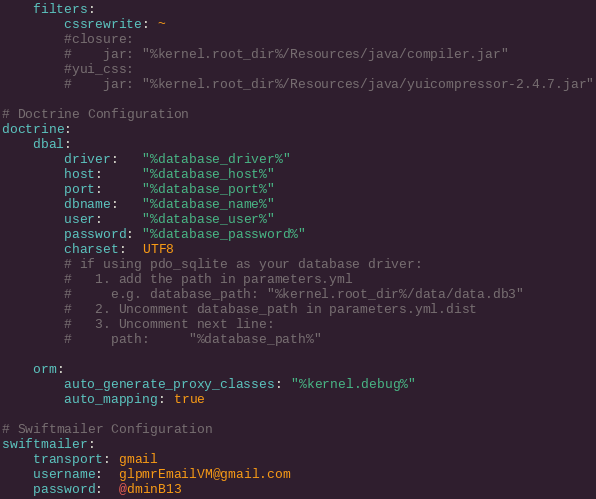Convert code to text. <code><loc_0><loc_0><loc_500><loc_500><_YAML_>    filters:
        cssrewrite: ~
        #closure:
        #    jar: "%kernel.root_dir%/Resources/java/compiler.jar"
        #yui_css:
        #    jar: "%kernel.root_dir%/Resources/java/yuicompressor-2.4.7.jar"

# Doctrine Configuration
doctrine:
    dbal:
        driver:   "%database_driver%"
        host:     "%database_host%"
        port:     "%database_port%"
        dbname:   "%database_name%"
        user:     "%database_user%"
        password: "%database_password%"
        charset:  UTF8
        # if using pdo_sqlite as your database driver:
        #   1. add the path in parameters.yml
        #     e.g. database_path: "%kernel.root_dir%/data/data.db3"
        #   2. Uncomment database_path in parameters.yml.dist
        #   3. Uncomment next line:
        #     path:     "%database_path%"

    orm:
        auto_generate_proxy_classes: "%kernel.debug%"
        auto_mapping: true

# Swiftmailer Configuration
swiftmailer:
    transport: gmail
    username:  glpmrEmailVM@gmail.com
    password:  @dminB13
</code> 